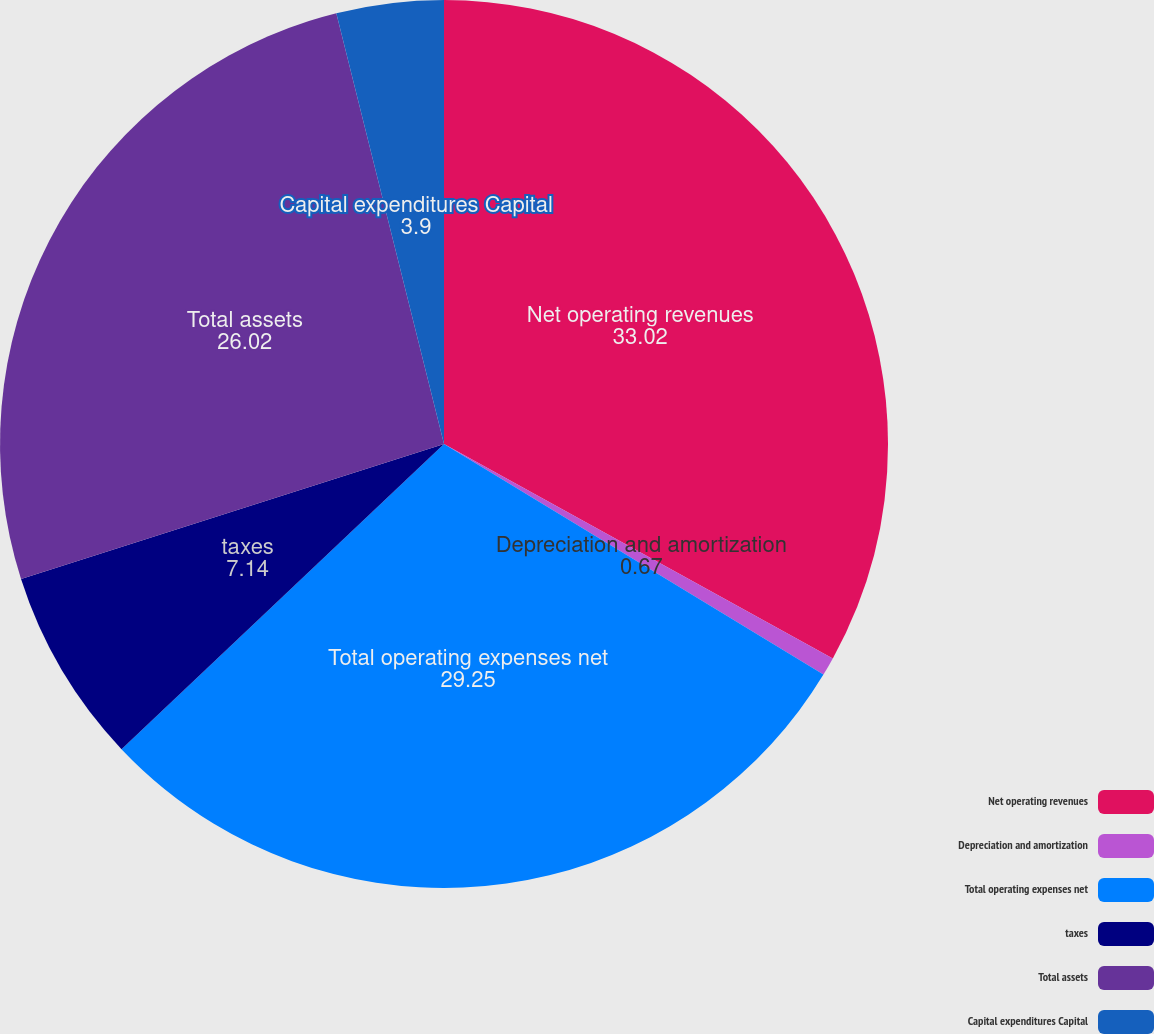Convert chart. <chart><loc_0><loc_0><loc_500><loc_500><pie_chart><fcel>Net operating revenues<fcel>Depreciation and amortization<fcel>Total operating expenses net<fcel>taxes<fcel>Total assets<fcel>Capital expenditures Capital<nl><fcel>33.02%<fcel>0.67%<fcel>29.25%<fcel>7.14%<fcel>26.02%<fcel>3.9%<nl></chart> 